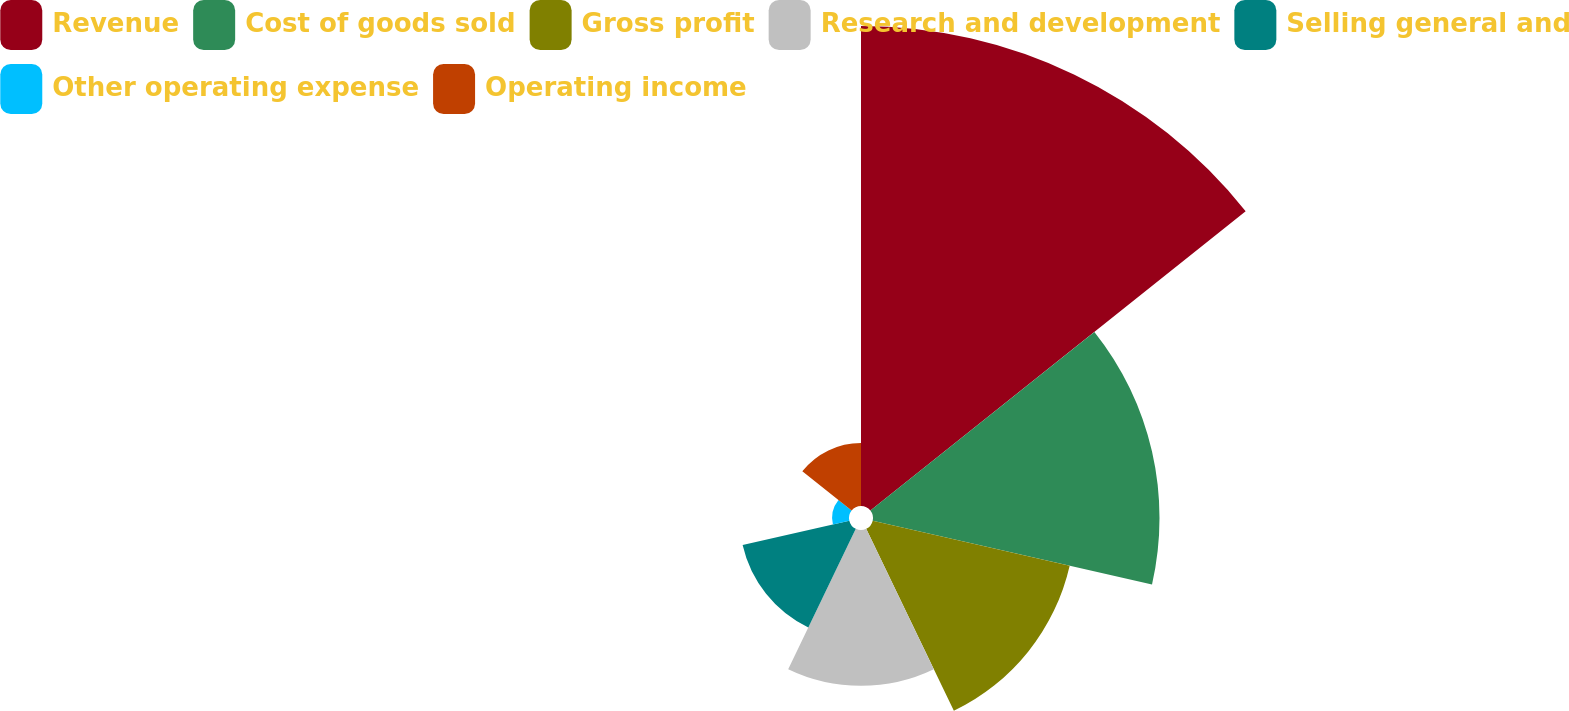Convert chart. <chart><loc_0><loc_0><loc_500><loc_500><pie_chart><fcel>Revenue<fcel>Cost of goods sold<fcel>Gross profit<fcel>Research and development<fcel>Selling general and<fcel>Other operating expense<fcel>Operating income<nl><fcel>36.54%<fcel>21.81%<fcel>15.38%<fcel>11.86%<fcel>8.33%<fcel>1.28%<fcel>4.8%<nl></chart> 